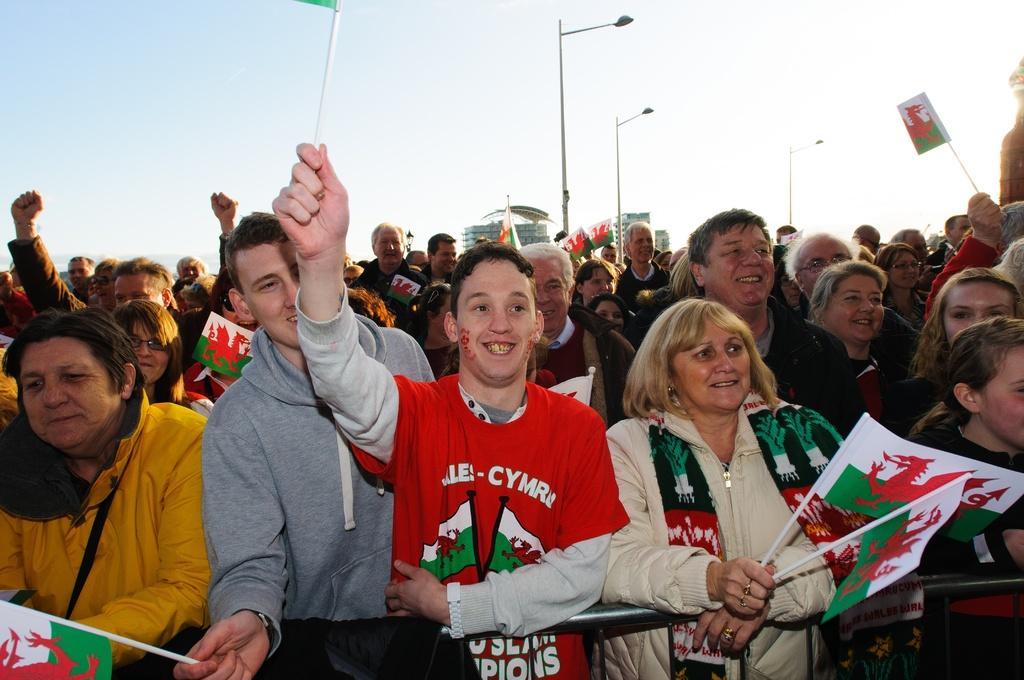Can you describe this image briefly? In this picture we can see a group of people standing, flags, fence, poles, lamps, buildings and in the background we can see the sky. 